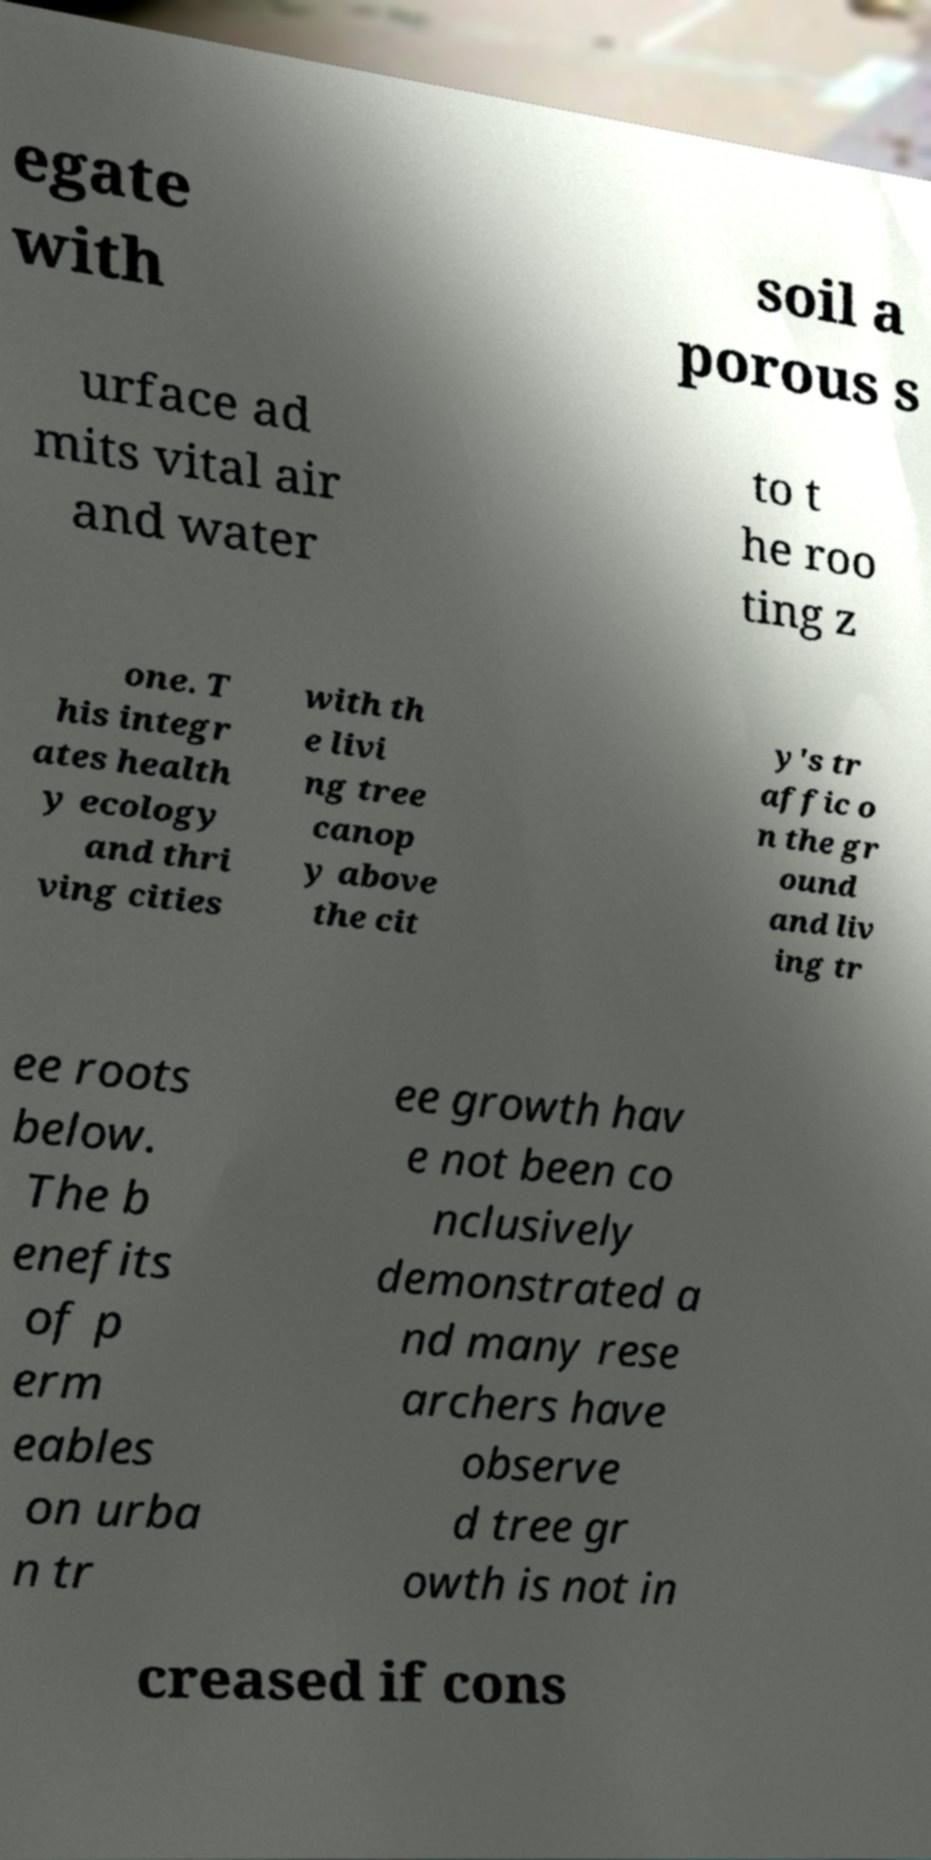Could you assist in decoding the text presented in this image and type it out clearly? egate with soil a porous s urface ad mits vital air and water to t he roo ting z one. T his integr ates health y ecology and thri ving cities with th e livi ng tree canop y above the cit y's tr affic o n the gr ound and liv ing tr ee roots below. The b enefits of p erm eables on urba n tr ee growth hav e not been co nclusively demonstrated a nd many rese archers have observe d tree gr owth is not in creased if cons 